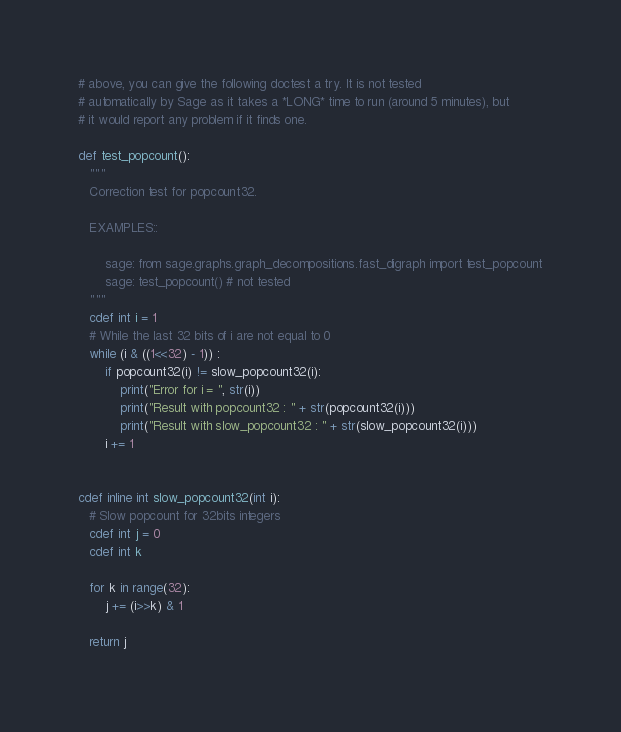Convert code to text. <code><loc_0><loc_0><loc_500><loc_500><_Cython_># above, you can give the following doctest a try. It is not tested
# automatically by Sage as it takes a *LONG* time to run (around 5 minutes), but
# it would report any problem if it finds one.

def test_popcount():
   """
   Correction test for popcount32.

   EXAMPLES::

       sage: from sage.graphs.graph_decompositions.fast_digraph import test_popcount
       sage: test_popcount() # not tested
   """
   cdef int i = 1
   # While the last 32 bits of i are not equal to 0
   while (i & ((1<<32) - 1)) :
       if popcount32(i) != slow_popcount32(i):
           print("Error for i = ", str(i))
           print("Result with popcount32 : " + str(popcount32(i)))
           print("Result with slow_popcount32 : " + str(slow_popcount32(i)))
       i += 1


cdef inline int slow_popcount32(int i):
   # Slow popcount for 32bits integers
   cdef int j = 0
   cdef int k

   for k in range(32):
       j += (i>>k) & 1

   return j
</code> 